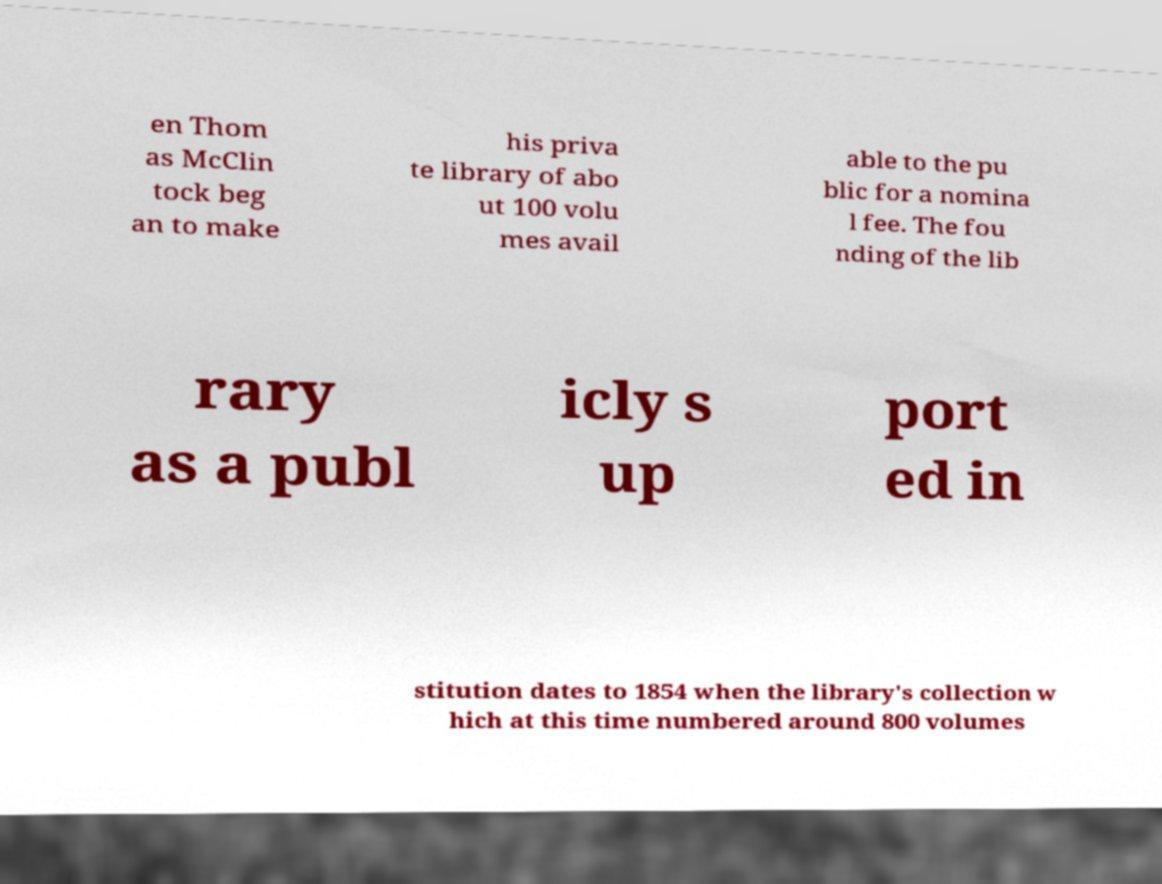Could you extract and type out the text from this image? en Thom as McClin tock beg an to make his priva te library of abo ut 100 volu mes avail able to the pu blic for a nomina l fee. The fou nding of the lib rary as a publ icly s up port ed in stitution dates to 1854 when the library's collection w hich at this time numbered around 800 volumes 